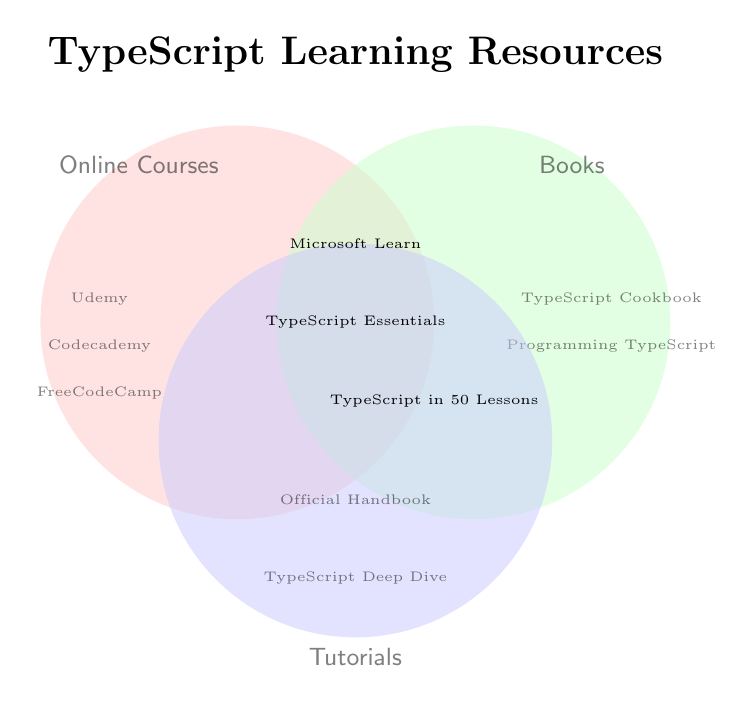What resources are found only in the Tutorials section? The resources that are exclusively in the Tutorials section are listed only within the single circle labeled "Tutorials". Two such resources are mentioned.
Answer: Official TypeScript Handbook, TypeScript Deep Dive Which resource is common to all three categories: Online Courses, Books, and Tutorials? The common resource is located where all three circles overlap, as it is included in Online Courses, Books, and Tutorials. The overlap shows a single resource.
Answer: TypeScript Essentials How many resources are there in total within the Online Courses category, including overlaps? The count includes resources solely in the Online Courses circle and those in overlapping areas that include Online Courses. We count them: Udemy, Codecademy, FreeCodeCamp, Microsoft Learn, TypeScript Essentials (5 total).
Answer: 5 Is there any resource that is common to only Online Courses and Tutorials, but not Books? This question focuses on the intersection of Online Courses and Tutorials, excluding Books. The intersection only shows one resource.
Answer: Microsoft Learn TypeScript List the resources that are common to Books and Tutorials but not Online Courses. This question seeks resources in the intersection between Books and Tutorials, excluding the Online Courses circle. There is one resource shown in this area.
Answer: TypeScript in 50 Lessons Which categories share the resource 'Microsoft Learn TypeScript'? We look for the segment labeled with 'Microsoft Learn TypeScript' and see which circles intersect at this point. It is within the area shared by Online Courses and Tutorials.
Answer: Online Courses, Tutorials How many resources are exclusive to the Books category? We need to count the resources only within the Books circle and not in any overlaps. Two resources are solely in the Books area.
Answer: 2 Name the resources that are part of either Books or Tutorials, but not Online Courses. We look for all resources in Books and Tutorials, excluding any resources present in the Online Courses circle. In Books: TypeScript Cookbook, Programming TypeScript. In Tutorials: Official TypeScript Handbook, TypeScript Deep Dive. In Books and Tutorials: TypeScript in 50 Lessons.
Answer: TypeScript Cookbook, Programming TypeScript, Official TypeScript Handbook, TypeScript Deep Dive, TypeScript in 50 Lessons 